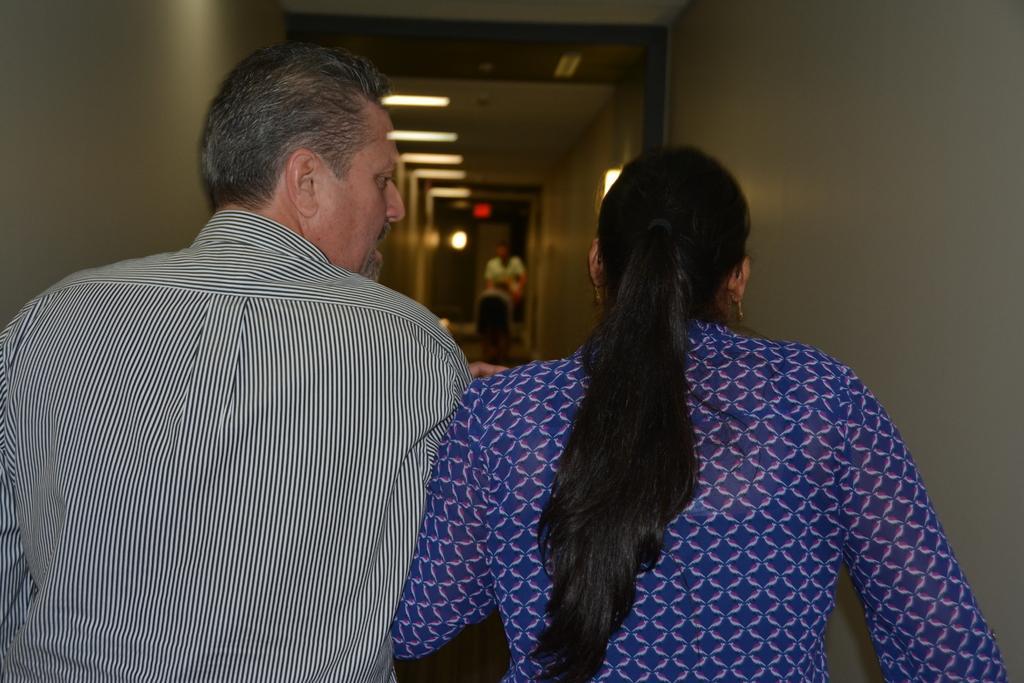Who are the two main subjects in the image? There is a man and a lady in the image. Can you describe the setting of the image? There are other people in the background of the image, and there are lights visible. There is also a wall and a roof in the image. How many people can be seen in the image? There are at least two people (the man and the lady) and other people in the background. What type of agreement is being discussed by the pigs in the image? There are no pigs present in the image, so no agreement can be discussed. 